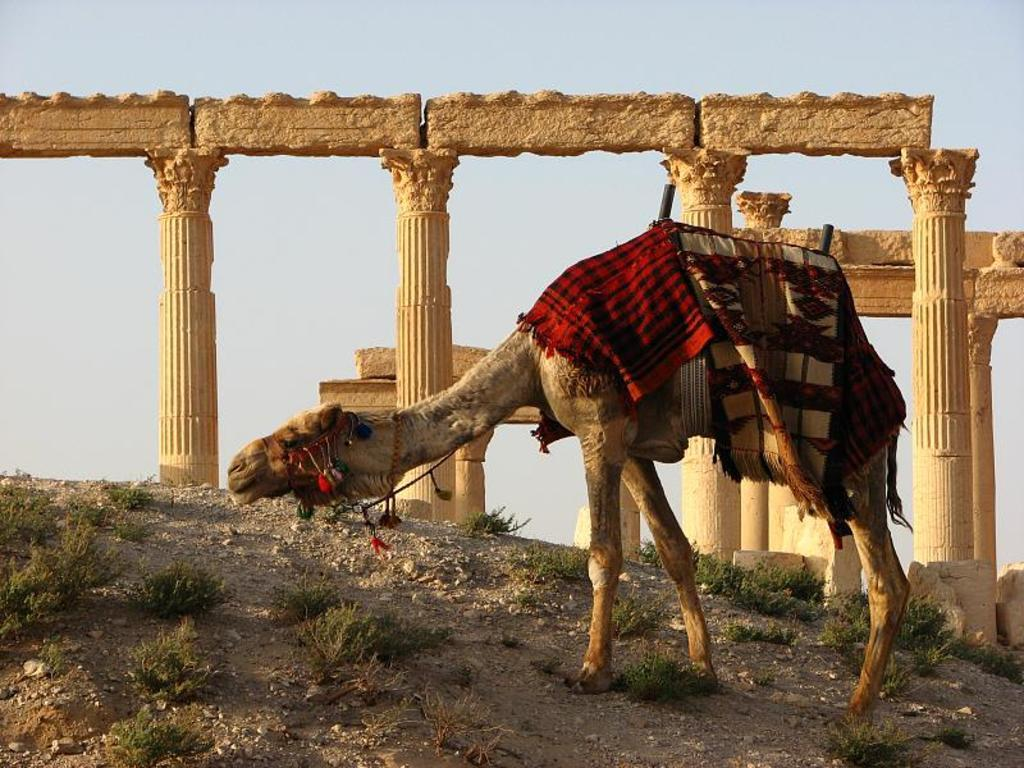What animal is the main subject of the image? There is a camel in the image. What is covering the camel? The camel has colorful cloth on it. What can be seen in the background of the image? There are cream-colored pillars in the background. What type of vegetation is visible in the image? There is grass visible in the image. What type of ground surface is present in the image? There are small stones in the image. What is the color of the sky in the image? The sky is blue and white in color. What is the name of the camel's daughter in the image? There is no mention of a daughter or any other camel in the image. How many horses are present in the image? There are no horses present in the image; it features a camel with colorful cloth. 